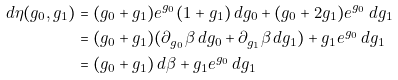Convert formula to latex. <formula><loc_0><loc_0><loc_500><loc_500>d \eta ( g _ { 0 } , g _ { 1 } ) & = ( g _ { 0 } + g _ { 1 } ) e ^ { g _ { 0 } } ( 1 + g _ { 1 } ) \, d g _ { 0 } + ( g _ { 0 } + 2 g _ { 1 } ) e ^ { g _ { 0 } } \, d g _ { 1 } \\ & = ( g _ { 0 } + g _ { 1 } ) ( \partial _ { g _ { 0 } } \beta \, d g _ { 0 } + \partial _ { g _ { 1 } } \beta \, d g _ { 1 } ) + g _ { 1 } e ^ { g _ { 0 } } \, d g _ { 1 } \\ & = ( g _ { 0 } + g _ { 1 } ) \, d \beta + g _ { 1 } e ^ { g _ { 0 } } \, d g _ { 1 }</formula> 